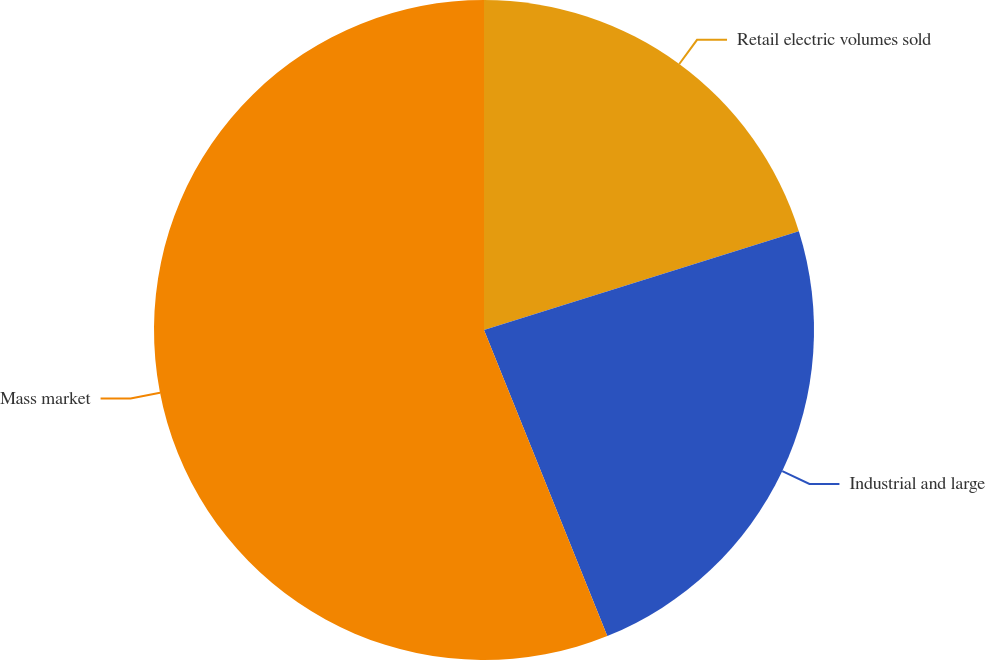Convert chart. <chart><loc_0><loc_0><loc_500><loc_500><pie_chart><fcel>Retail electric volumes sold<fcel>Industrial and large<fcel>Mass market<nl><fcel>20.16%<fcel>23.75%<fcel>56.1%<nl></chart> 